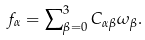<formula> <loc_0><loc_0><loc_500><loc_500>f _ { \alpha } = \sum \nolimits _ { \beta = 0 } ^ { 3 } C _ { \alpha \beta } \omega _ { \beta } .</formula> 